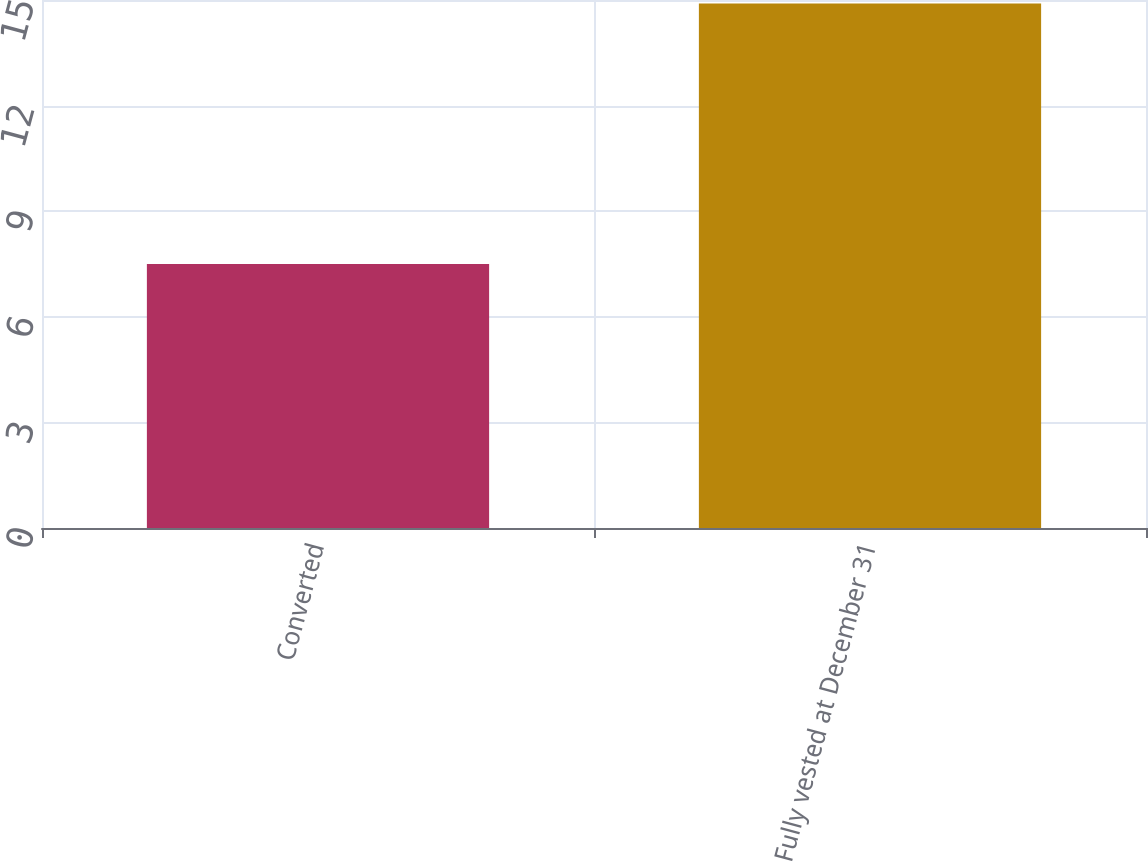<chart> <loc_0><loc_0><loc_500><loc_500><bar_chart><fcel>Converted<fcel>Fully vested at December 31<nl><fcel>7.5<fcel>14.9<nl></chart> 